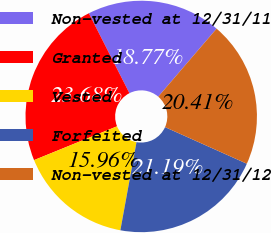<chart> <loc_0><loc_0><loc_500><loc_500><pie_chart><fcel>Non-vested at 12/31/11<fcel>Granted<fcel>Vested<fcel>Forfeited<fcel>Non-vested at 12/31/12<nl><fcel>18.77%<fcel>23.68%<fcel>15.96%<fcel>21.19%<fcel>20.41%<nl></chart> 